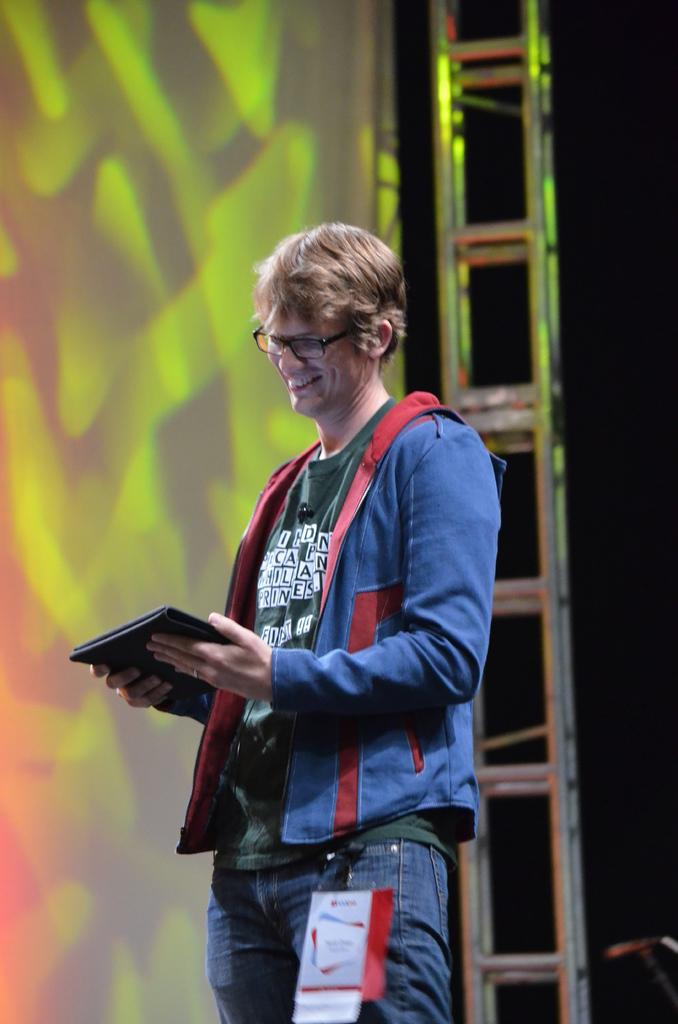What is the person in the image doing? The person is standing on a dais in the image. What object is the person holding? The person is holding a tablet. What can be seen in the background of the image? There is a ladder and a screen in the background of the image. How does the person adjust the side of the screen in the image? There is no indication in the image that the person is adjusting the side of the screen, as the person is holding a tablet and there is no interaction with the screen mentioned in the facts. 